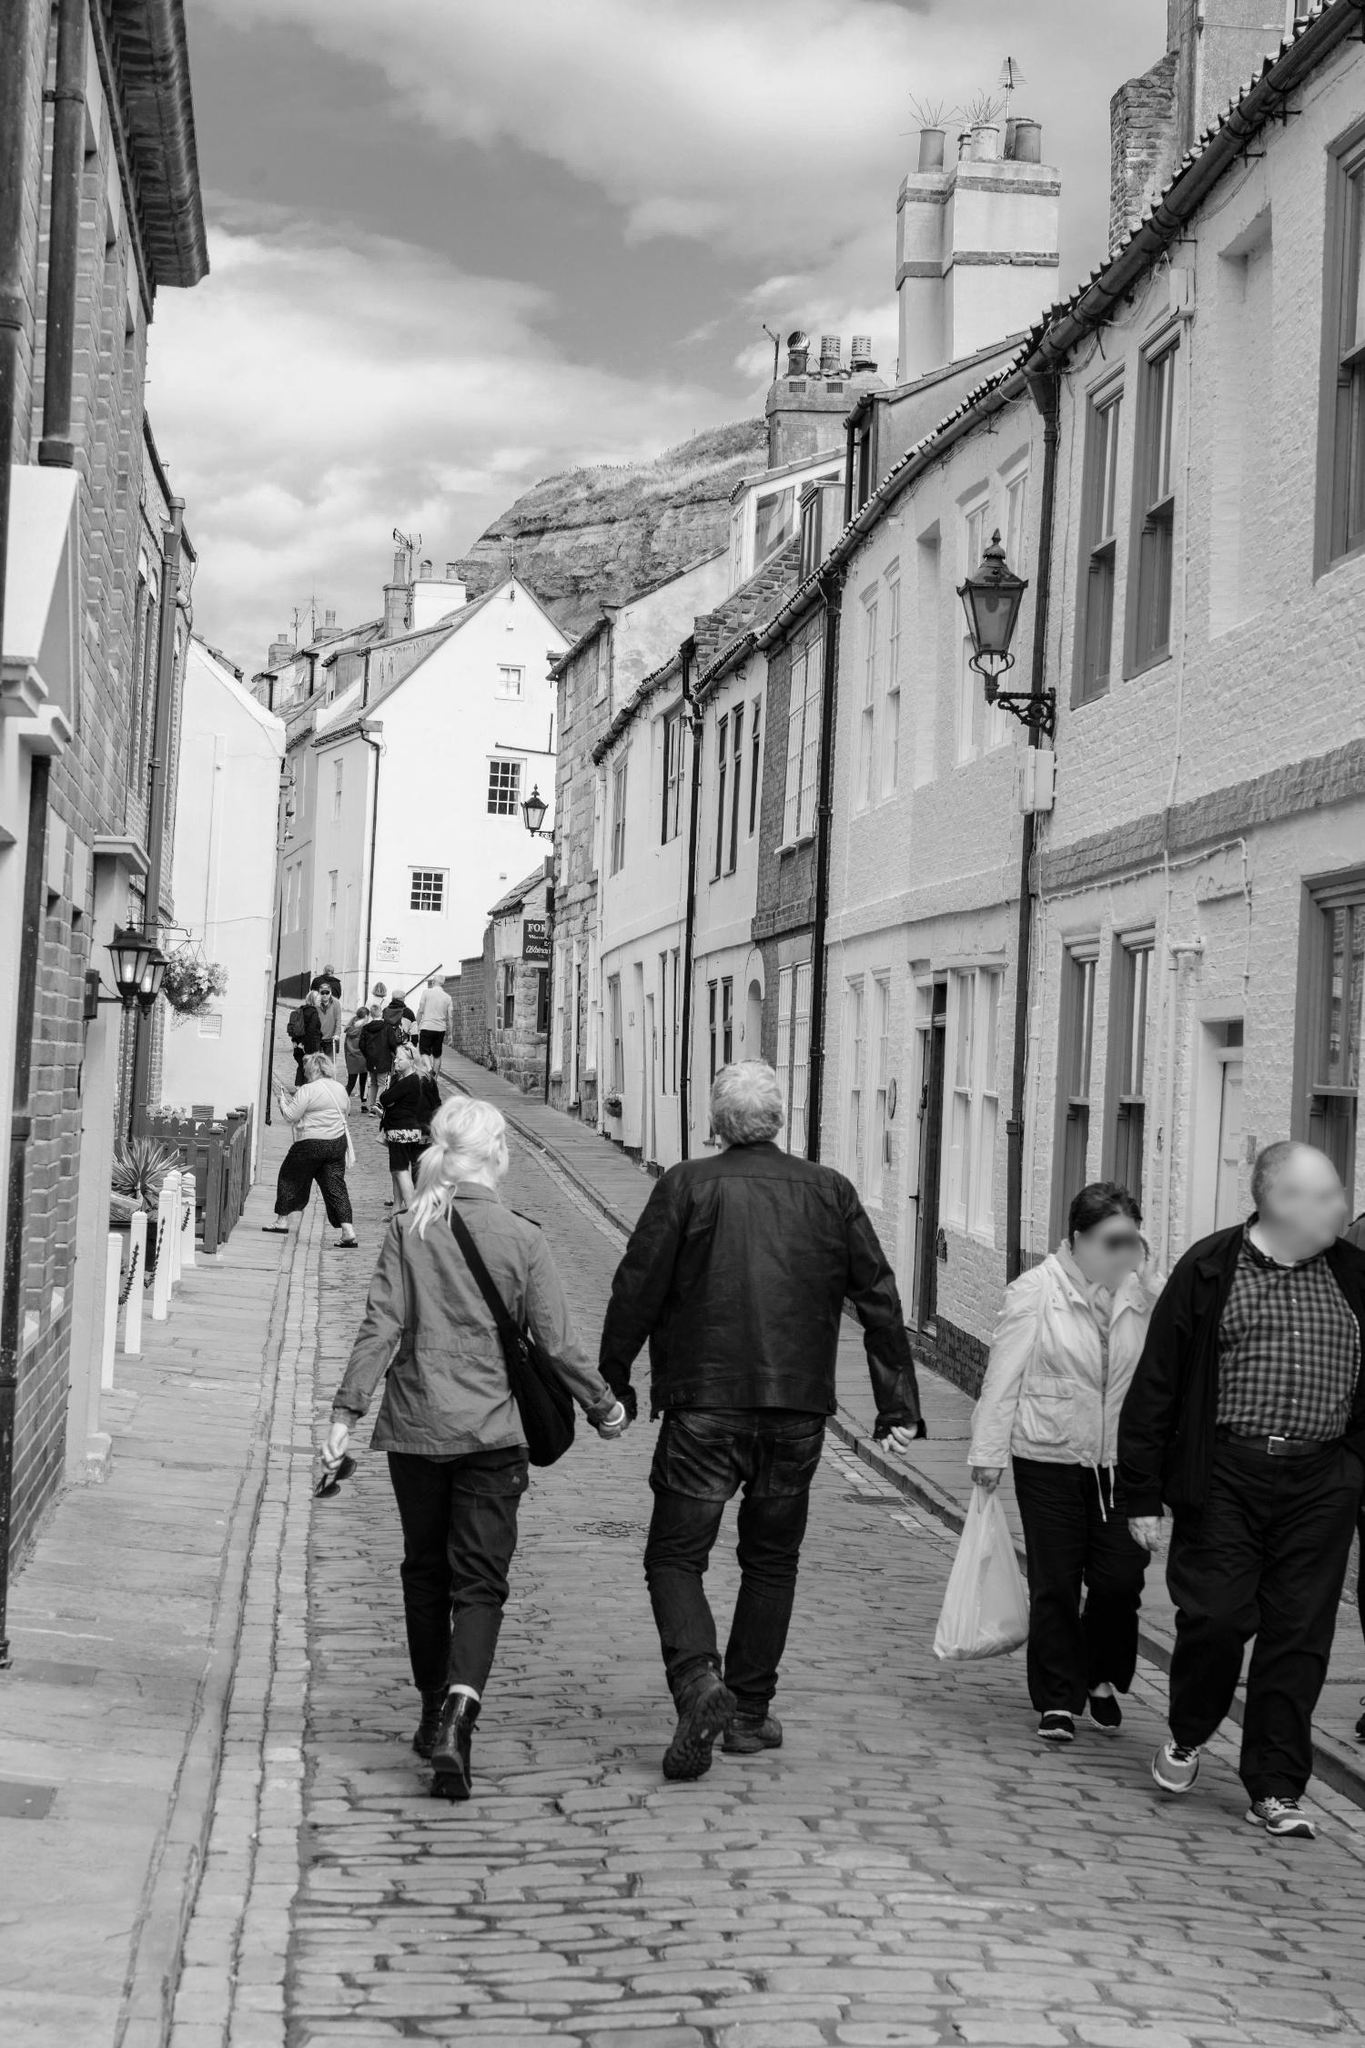What kind of stories could have happened on this cobblestone street? This cobblestone street has likely seen a tapestry of human stories unfold over the years. Perhaps a young couple met by chance many years ago and fell in love while strolling up the street together. In another era, a war-time messenger might have hurried through with urgent news, his footsteps echoing off the stone walls. On a quieter note, a street vendor could have hawked his fresh produce from a wooden cart, while children played nearby, their laughter filling the air. The castle in the backdrop has likely seen rulers and revolutions, its watchtower a silent witness to the passage of time and the myriad tales that these stones have quietly supported. 